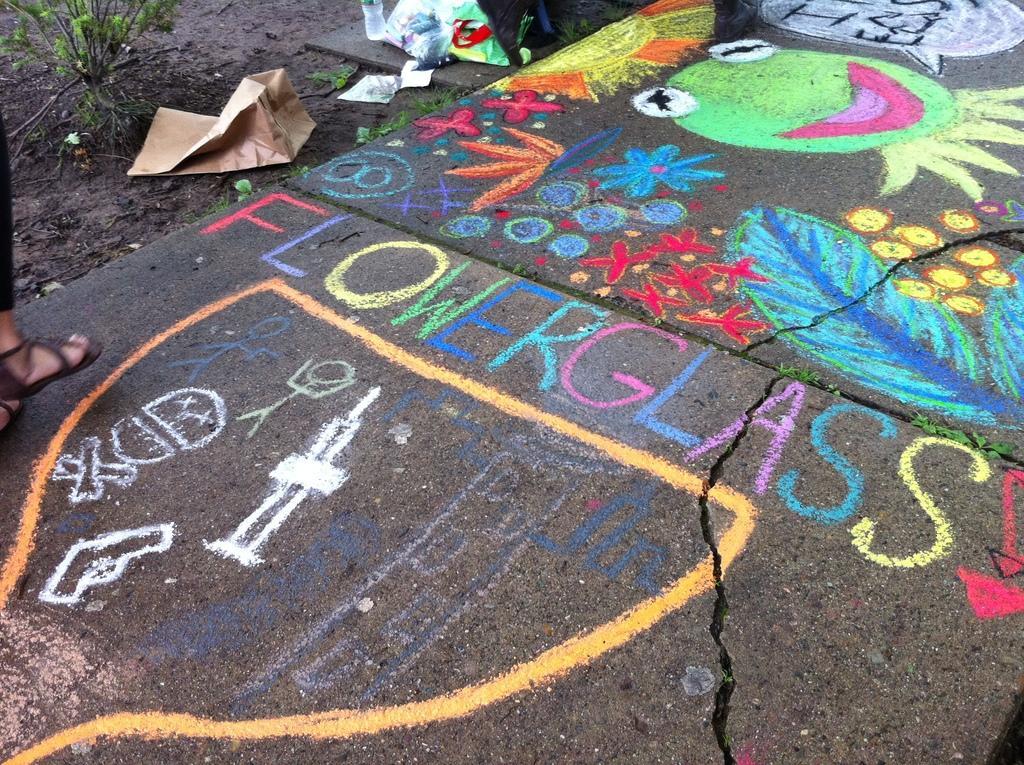Please provide a concise description of this image. In this image I see the ground on which I see rangoli which is colorful and I see an animal face over here and I see a word written over here and I see brown color bag over here and I see a person's legs over here and I see a plant over here. 